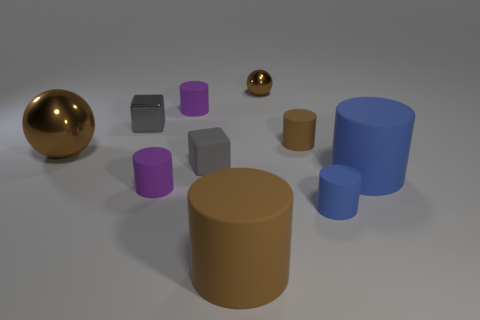Subtract all blue cylinders. How many cylinders are left? 4 Subtract 1 cylinders. How many cylinders are left? 5 Subtract all small blue cylinders. How many cylinders are left? 5 Subtract all cyan cylinders. Subtract all gray blocks. How many cylinders are left? 6 Subtract all spheres. How many objects are left? 8 Add 1 gray matte cubes. How many gray matte cubes are left? 2 Add 1 big matte cylinders. How many big matte cylinders exist? 3 Subtract 1 gray cubes. How many objects are left? 9 Subtract all tiny gray shiny cubes. Subtract all tiny matte cylinders. How many objects are left? 5 